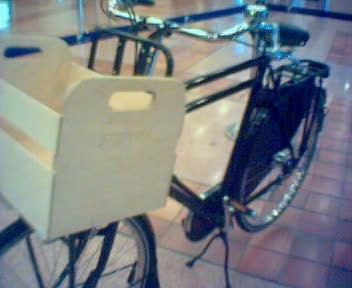Would there be a bicycle in the image if the bicycle was not in the picture? If the bicycle were not present in the image, we would not see it. However, the absence of the bicycle would reveal more of the environment it is currently obscuring, such as the flooring and any objects directly behind it. 